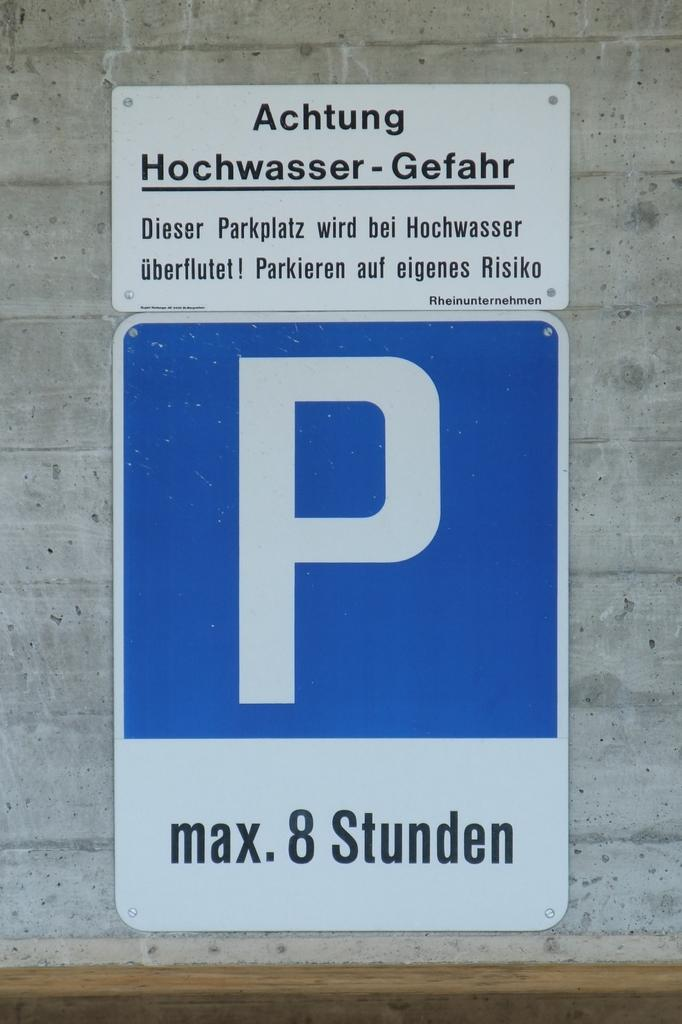Provide a one-sentence caption for the provided image. Sign on a wall that has a large P on it and says Max 8 studen. 